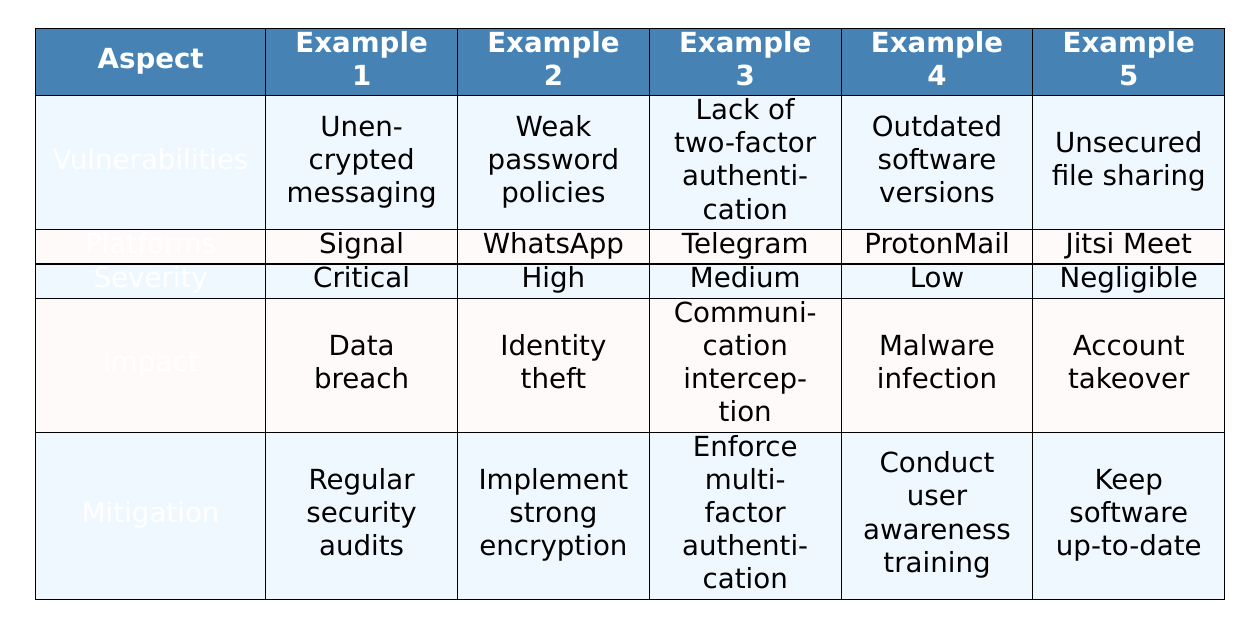What are the three vulnerabilities listed in the table? The table lists a total of ten vulnerabilities, from which the first three are "Unencrypted messaging," "Weak password policies," and "Lack of two-factor authentication."
Answer: Unencrypted messaging, Weak password policies, Lack of two-factor authentication Which platform is associated with the "Critical" severity level? The table indicates that the "Critical" severity level is associated with the vulnerability "Unencrypted messaging." The platform for this vulnerability is "Signal," as it is listed directly under the "Vulnerabilities" row.
Answer: Signal Is "ProtonMail" listed as having any vulnerabilities? By checking the "Platforms" row, I notice that "ProtonMail" appears. However, it does not align with any vulnerabilities in the "Vulnerabilities" row, indicating that "ProtonMail" does not have a listed vulnerability.
Answer: No What is the impact of the vulnerability labeled "Lack of two-factor authentication"? First, we locate "Lack of two-factor authentication" in the "Vulnerabilities" row, which is in the third position. From the "Impact" row, the third corresponding impact is "Communication interception."
Answer: Communication interception Which mitigation measures correspond to vulnerabilities with a "High" severity? By identifying the "High" severity noted in the table, we find "Weak password policies" under vulnerabilities. The corresponding mitigation for this vulnerability in the table is "Implement strong encryption," which is listed under the "Mitigation" row.
Answer: Implement strong encryption What vulnerabilities have impacts related to "Identity theft" and "Data breach"? To find this, I examine the "Impact" row. "Data breach" corresponds to the first vulnerability, "Unencrypted messaging," and "Identity theft" corresponds to the second vulnerability, "Weak password policies." Therefore, the vulnerabilities associated with these impacts are "Unencrypted messaging" and "Weak password policies."
Answer: Unencrypted messaging, Weak password policies How many mitigation strategies are listed in the table? The table contains a "Mitigation" row with a total of ten listed strategies. Since each strategy is a countable item in this row, I confirm that there are ten unique mitigation measures.
Answer: Ten What severity level is associated with "Unsecured file sharing"? I find "Unsecured file sharing" listed in the "Vulnerabilities" row as the fifth item. It corresponds to "Negligible" severity level listed in the "Severity" row, as it occupies the fifth position.
Answer: Negligible Which platform listed has the lowest severity rating according to the data? The table states that "Negligible" is the lowest severity level. The vulnerability associated with this severity is "Unsecured file sharing," which corresponds to "Jitsi Meet" in the platforms row.
Answer: Jitsi Meet What measures can be taken to mitigate a "Malware infection"? The vulnerability leading to a "Malware infection" can be found as the fourth impact in the "Impact" row. The corresponding vulnerability related to it, which is not explicitly shown, corresponds to the mitigation strategies above. The table does not specify a direct connection but "Keep software up-to-date" is a general mitigation useful against malware infections.
Answer: Keep software up-to-date 